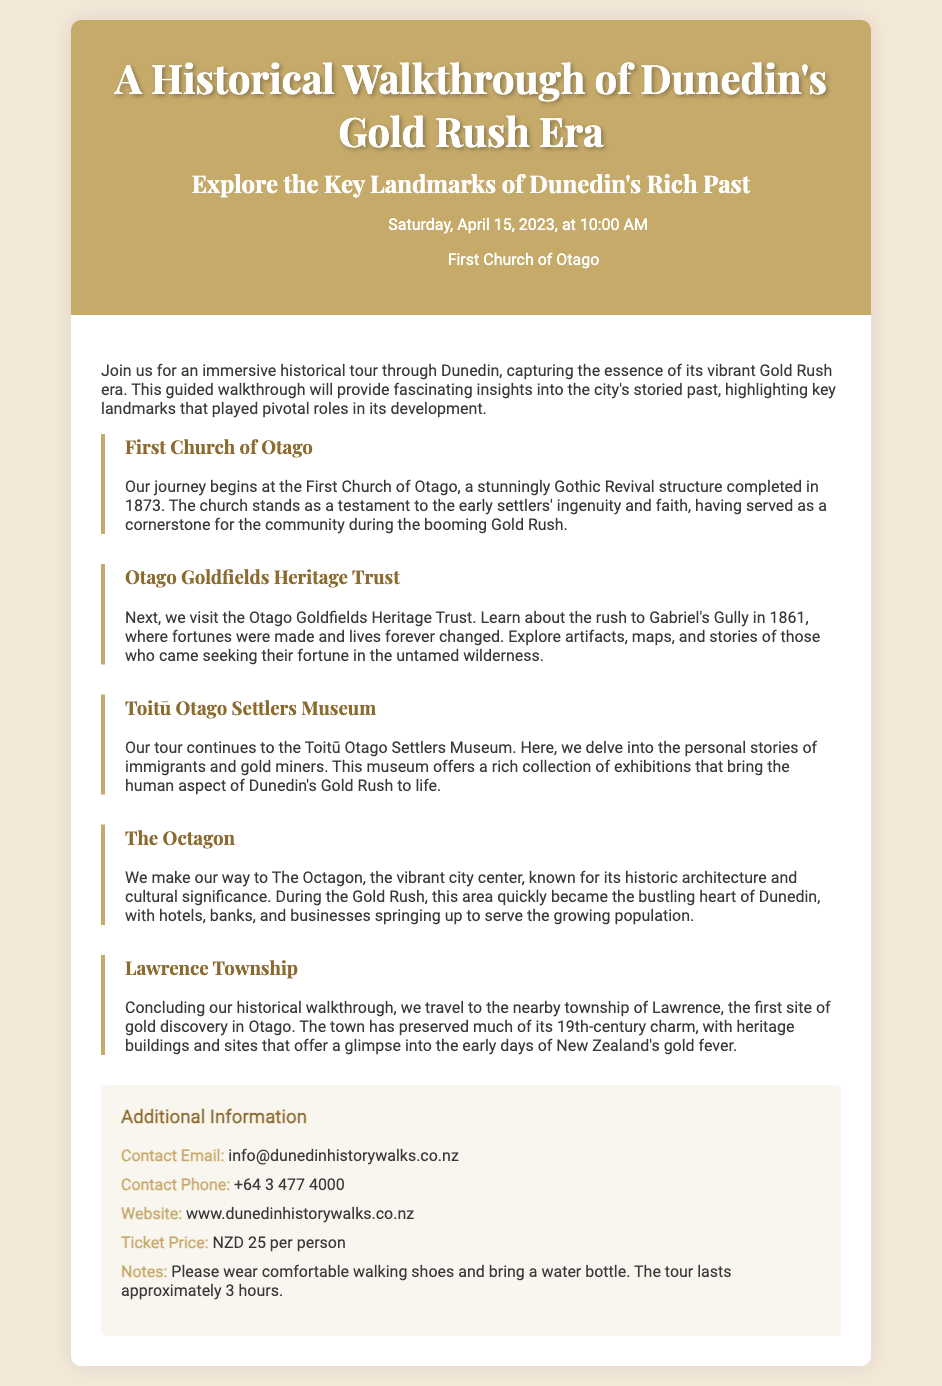What is the date of the walkthrough? The date of the walkthrough is mentioned in the header of the document.
Answer: Saturday, April 15, 2023 Where does the tour start? The starting point is specified in the header section of the document.
Answer: First Church of Otago What is the ticket price for the tour? The ticket price is listed in the additional information section of the document.
Answer: NZD 25 per person Which landmark is the last stop of the tour? The last stop is described in the concluding section of the tour.
Answer: Lawrence Township What significant event regarding the Otago Goldfields is highlighted? The document mentions a specific event related to gold discovery in its sections.
Answer: The rush to Gabriel's Gully in 1861 What type of museum is the Toitū Otago Settlers Museum? The document describes the museum's focus in its section.
Answer: Settlers Museum How long does the tour last? The duration of the tour is provided in the notes section of the document.
Answer: Approximately 3 hours What color is used for the accent in the document? The specific color of the accent is referenced in the style section as well as visually represented.
Answer: Gold 